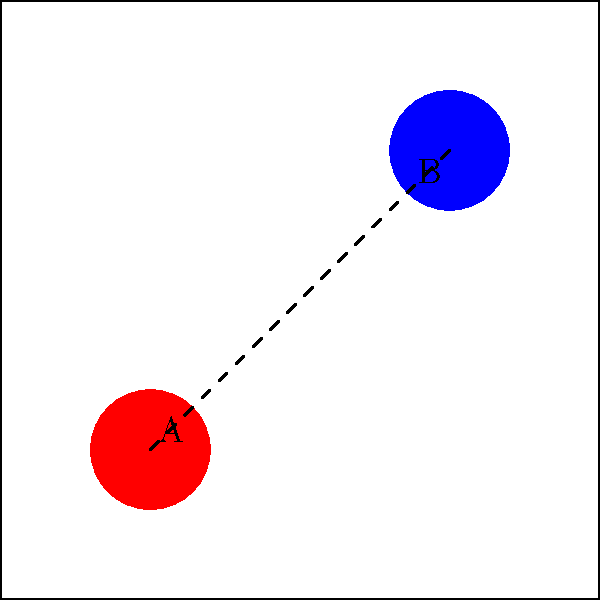In a maze-style arcade game, two power-ups A and B are connected by a path as shown in the diagram. The resulting space X is formed by the union of this path and the two circular power-ups. Calculate the fundamental group $\pi_1(X)$ of this space. To determine the fundamental group of the space X, we'll follow these steps:

1) First, observe that the space X is homotopy equivalent to a figure-eight shape, as the connecting path can be continuously deformed to a single point where the two circles meet.

2) The figure-eight shape is the wedge sum of two circles: $S^1 \vee S^1$.

3) By the Seifert-van Kampen theorem, the fundamental group of a wedge sum of spaces is the free product of the fundamental groups of those spaces.

4) The fundamental group of a circle $S^1$ is isomorphic to the integers $\mathbb{Z}$.

5) Therefore, the fundamental group of X is:

   $\pi_1(X) \cong \pi_1(S^1 \vee S^1) \cong \pi_1(S^1) * \pi_1(S^1) \cong \mathbb{Z} * \mathbb{Z}$

6) The free product $\mathbb{Z} * \mathbb{Z}$ is isomorphic to the free group on two generators, often denoted as $F_2$.
Answer: $F_2$ 